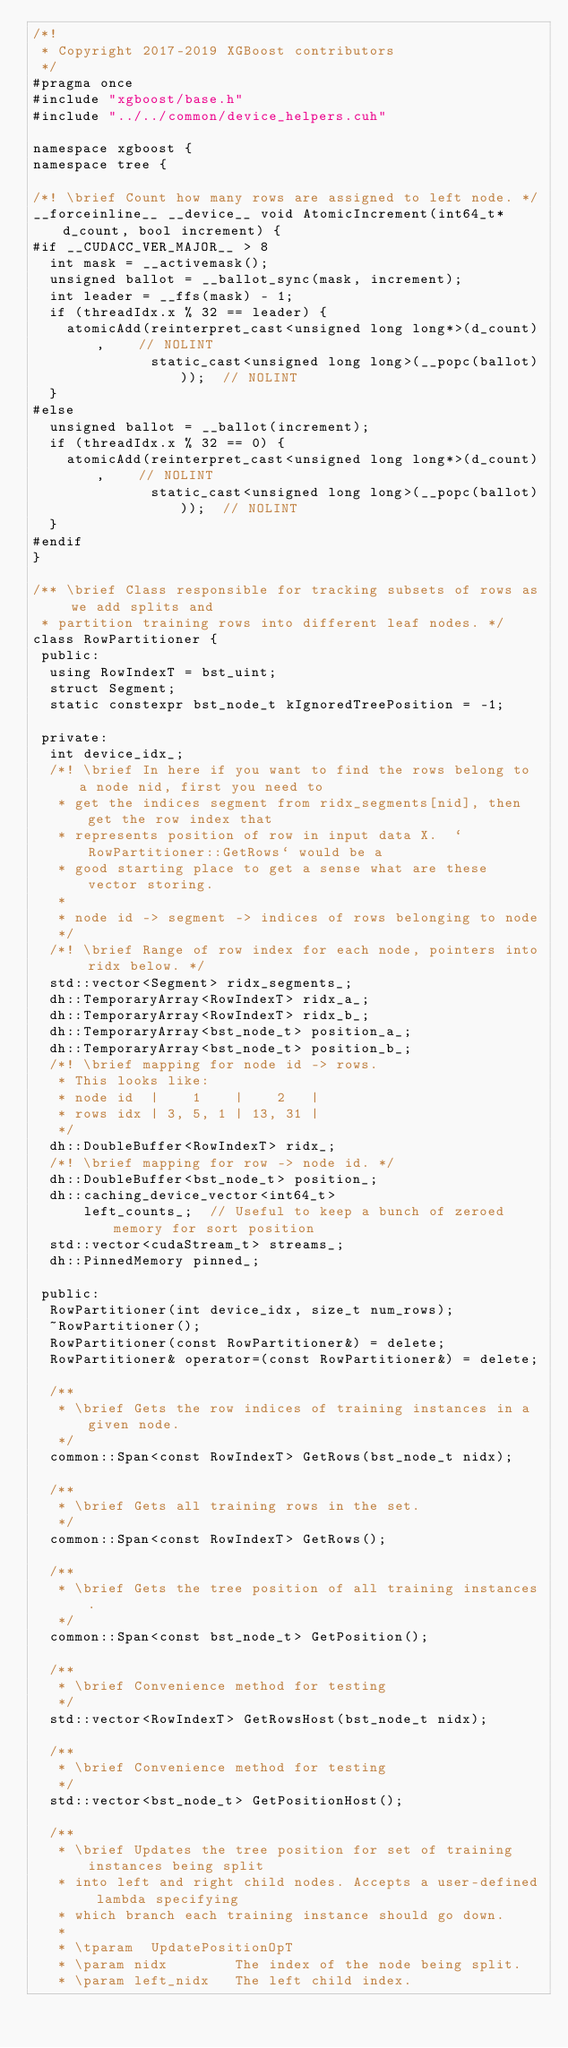<code> <loc_0><loc_0><loc_500><loc_500><_Cuda_>/*!
 * Copyright 2017-2019 XGBoost contributors
 */
#pragma once
#include "xgboost/base.h"
#include "../../common/device_helpers.cuh"

namespace xgboost {
namespace tree {

/*! \brief Count how many rows are assigned to left node. */
__forceinline__ __device__ void AtomicIncrement(int64_t* d_count, bool increment) {
#if __CUDACC_VER_MAJOR__ > 8
  int mask = __activemask();
  unsigned ballot = __ballot_sync(mask, increment);
  int leader = __ffs(mask) - 1;
  if (threadIdx.x % 32 == leader) {
    atomicAdd(reinterpret_cast<unsigned long long*>(d_count),    // NOLINT
              static_cast<unsigned long long>(__popc(ballot)));  // NOLINT
  }
#else
  unsigned ballot = __ballot(increment);
  if (threadIdx.x % 32 == 0) {
    atomicAdd(reinterpret_cast<unsigned long long*>(d_count),    // NOLINT
              static_cast<unsigned long long>(__popc(ballot)));  // NOLINT
  }
#endif
}

/** \brief Class responsible for tracking subsets of rows as we add splits and
 * partition training rows into different leaf nodes. */
class RowPartitioner {
 public:
  using RowIndexT = bst_uint;
  struct Segment;
  static constexpr bst_node_t kIgnoredTreePosition = -1;

 private:
  int device_idx_;
  /*! \brief In here if you want to find the rows belong to a node nid, first you need to
   * get the indices segment from ridx_segments[nid], then get the row index that
   * represents position of row in input data X.  `RowPartitioner::GetRows` would be a
   * good starting place to get a sense what are these vector storing.
   *
   * node id -> segment -> indices of rows belonging to node
   */
  /*! \brief Range of row index for each node, pointers into ridx below. */
  std::vector<Segment> ridx_segments_;
  dh::TemporaryArray<RowIndexT> ridx_a_;
  dh::TemporaryArray<RowIndexT> ridx_b_;
  dh::TemporaryArray<bst_node_t> position_a_;
  dh::TemporaryArray<bst_node_t> position_b_;
  /*! \brief mapping for node id -> rows.
   * This looks like:
   * node id  |    1    |    2   |
   * rows idx | 3, 5, 1 | 13, 31 |
   */
  dh::DoubleBuffer<RowIndexT> ridx_;
  /*! \brief mapping for row -> node id. */
  dh::DoubleBuffer<bst_node_t> position_;
  dh::caching_device_vector<int64_t>
      left_counts_;  // Useful to keep a bunch of zeroed memory for sort position
  std::vector<cudaStream_t> streams_;
  dh::PinnedMemory pinned_;

 public:
  RowPartitioner(int device_idx, size_t num_rows);
  ~RowPartitioner();
  RowPartitioner(const RowPartitioner&) = delete;
  RowPartitioner& operator=(const RowPartitioner&) = delete;

  /**
   * \brief Gets the row indices of training instances in a given node.
   */
  common::Span<const RowIndexT> GetRows(bst_node_t nidx);

  /**
   * \brief Gets all training rows in the set.
   */
  common::Span<const RowIndexT> GetRows();

  /**
   * \brief Gets the tree position of all training instances.
   */
  common::Span<const bst_node_t> GetPosition();

  /**
   * \brief Convenience method for testing
   */
  std::vector<RowIndexT> GetRowsHost(bst_node_t nidx);

  /**
   * \brief Convenience method for testing
   */
  std::vector<bst_node_t> GetPositionHost();

  /**
   * \brief Updates the tree position for set of training instances being split
   * into left and right child nodes. Accepts a user-defined lambda specifying
   * which branch each training instance should go down.
   *
   * \tparam  UpdatePositionOpT
   * \param nidx        The index of the node being split.
   * \param left_nidx   The left child index.</code> 